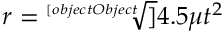Convert formula to latex. <formula><loc_0><loc_0><loc_500><loc_500>r = { \sqrt { [ } [ o b j e c t O b j e c t ] ] { 4 . 5 \mu t ^ { 2 } } }</formula> 